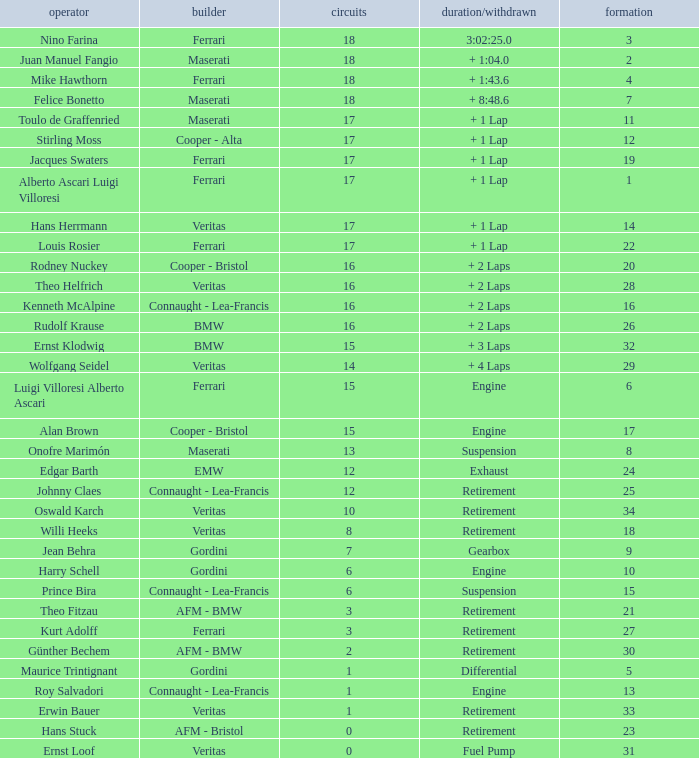Who has the low lap total in a maserati with grid 2? 18.0. 